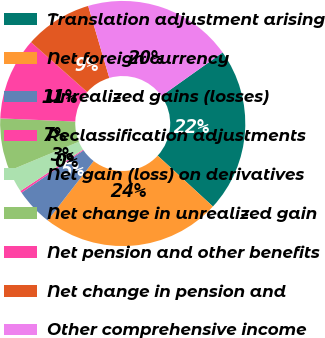Convert chart. <chart><loc_0><loc_0><loc_500><loc_500><pie_chart><fcel>Translation adjustment arising<fcel>Net foreign currency<fcel>Unrealized gains (losses)<fcel>Reclassification adjustments<fcel>Net gain (loss) on derivatives<fcel>Net change in unrealized gain<fcel>Net pension and other benefits<fcel>Net change in pension and<fcel>Other comprehensive income<nl><fcel>21.68%<fcel>23.65%<fcel>4.97%<fcel>0.27%<fcel>3.0%<fcel>6.94%<fcel>10.88%<fcel>8.91%<fcel>19.71%<nl></chart> 